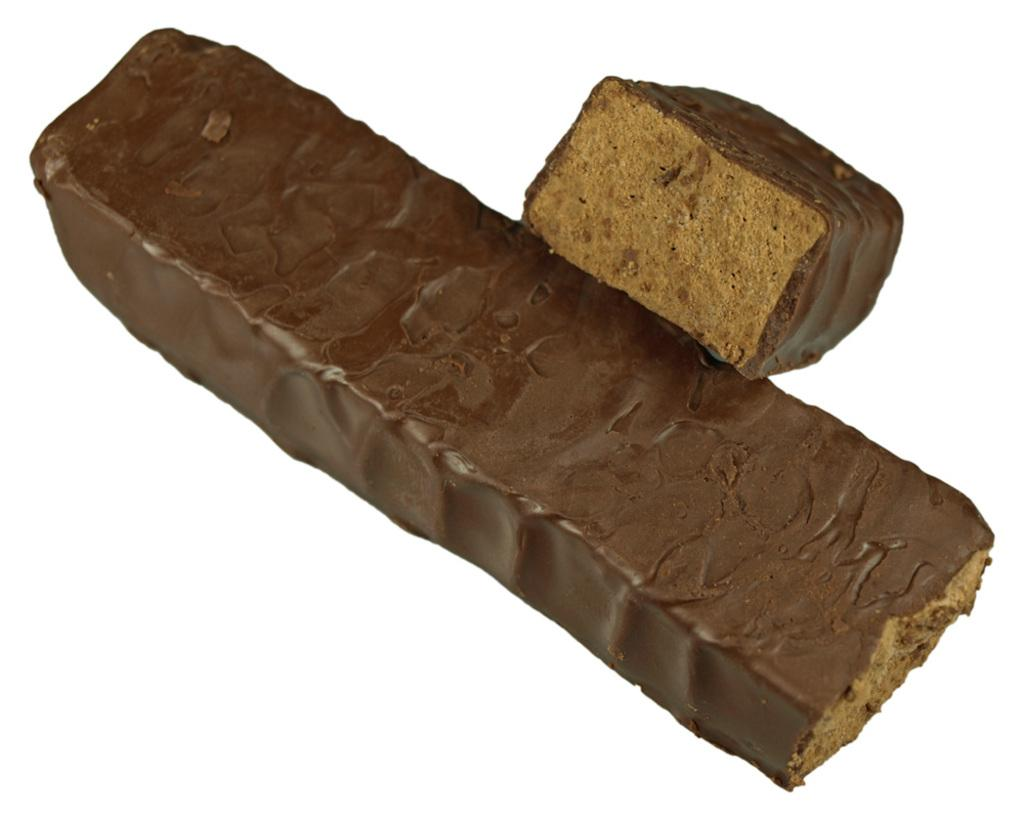What type of food can be seen in the image? There are two pieces of a chocolate bar in the image. What is the color of the chocolate bar? The chocolate bar is brown in color. What type of pot is used for expansion in the image? There is no pot or expansion activity present in the image; it only features two pieces of a chocolate bar. 